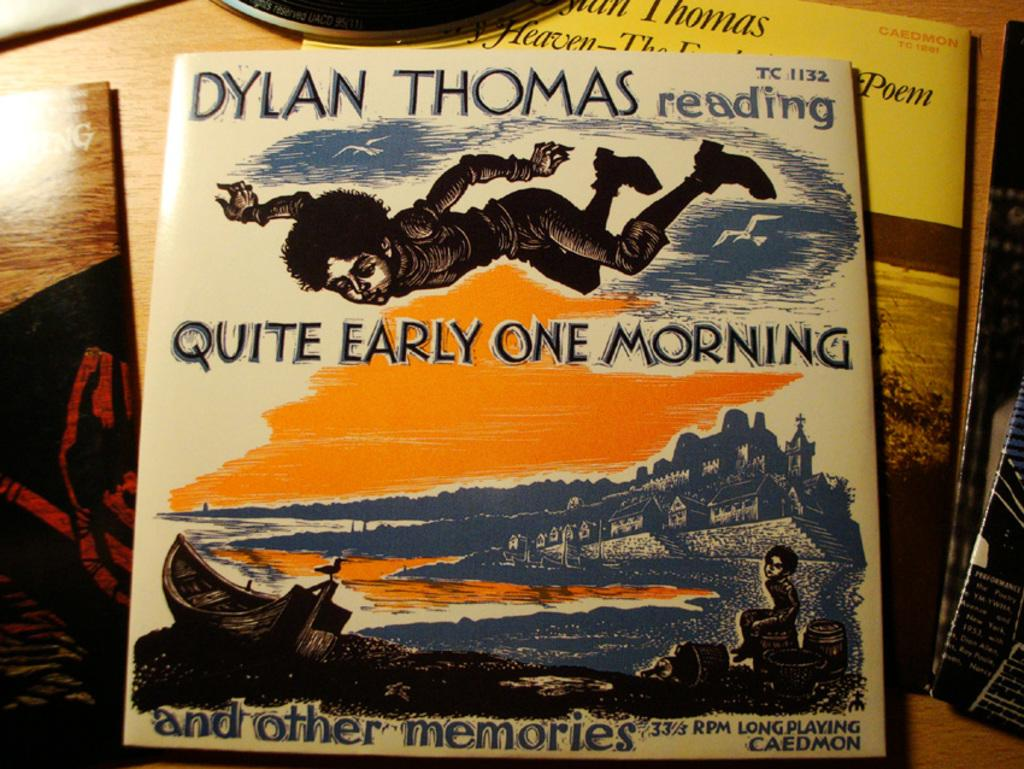<image>
Create a compact narrative representing the image presented. A book written by Dylan Thomas entitled Quite Early One Morning. 